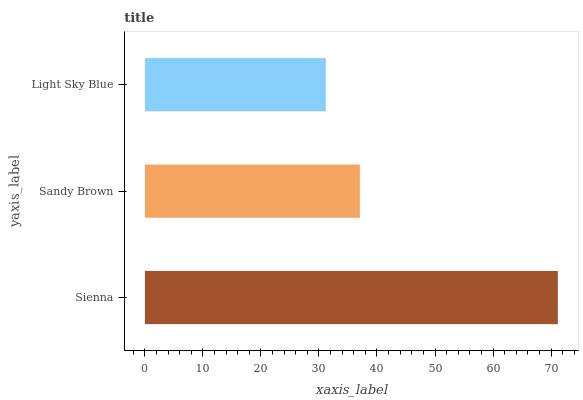Is Light Sky Blue the minimum?
Answer yes or no. Yes. Is Sienna the maximum?
Answer yes or no. Yes. Is Sandy Brown the minimum?
Answer yes or no. No. Is Sandy Brown the maximum?
Answer yes or no. No. Is Sienna greater than Sandy Brown?
Answer yes or no. Yes. Is Sandy Brown less than Sienna?
Answer yes or no. Yes. Is Sandy Brown greater than Sienna?
Answer yes or no. No. Is Sienna less than Sandy Brown?
Answer yes or no. No. Is Sandy Brown the high median?
Answer yes or no. Yes. Is Sandy Brown the low median?
Answer yes or no. Yes. Is Light Sky Blue the high median?
Answer yes or no. No. Is Sienna the low median?
Answer yes or no. No. 